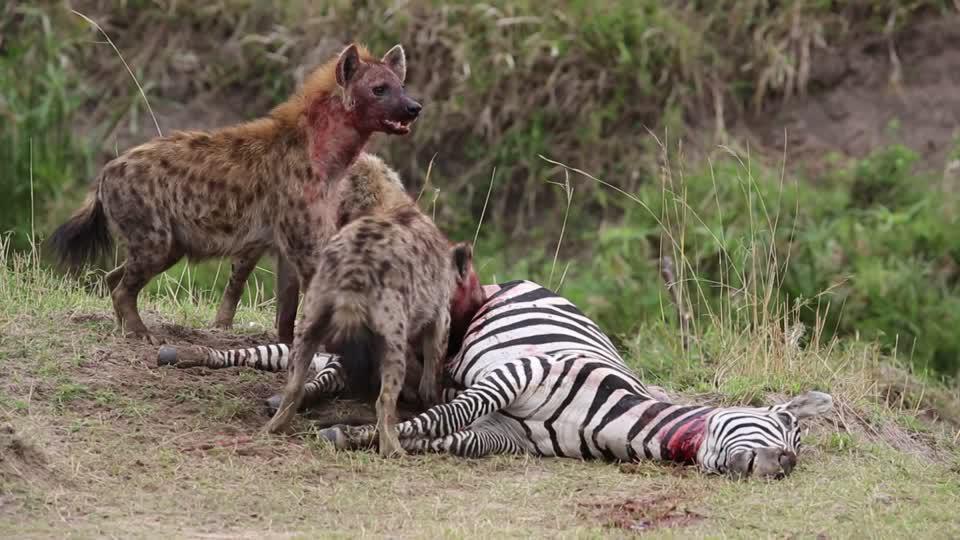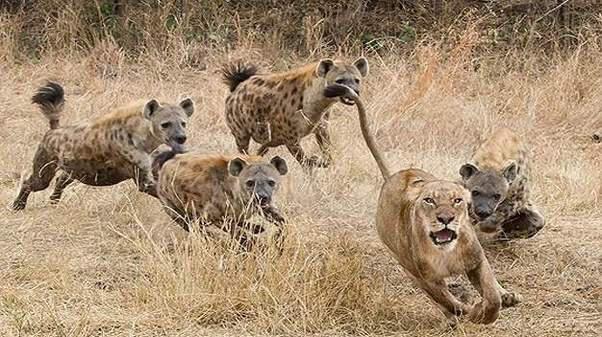The first image is the image on the left, the second image is the image on the right. For the images displayed, is the sentence "Multiple hyenas and one open-mouthed lion are engaged in action in one image." factually correct? Answer yes or no. Yes. The first image is the image on the left, the second image is the image on the right. For the images shown, is this caption "Hyenas are attacking a lion." true? Answer yes or no. Yes. 